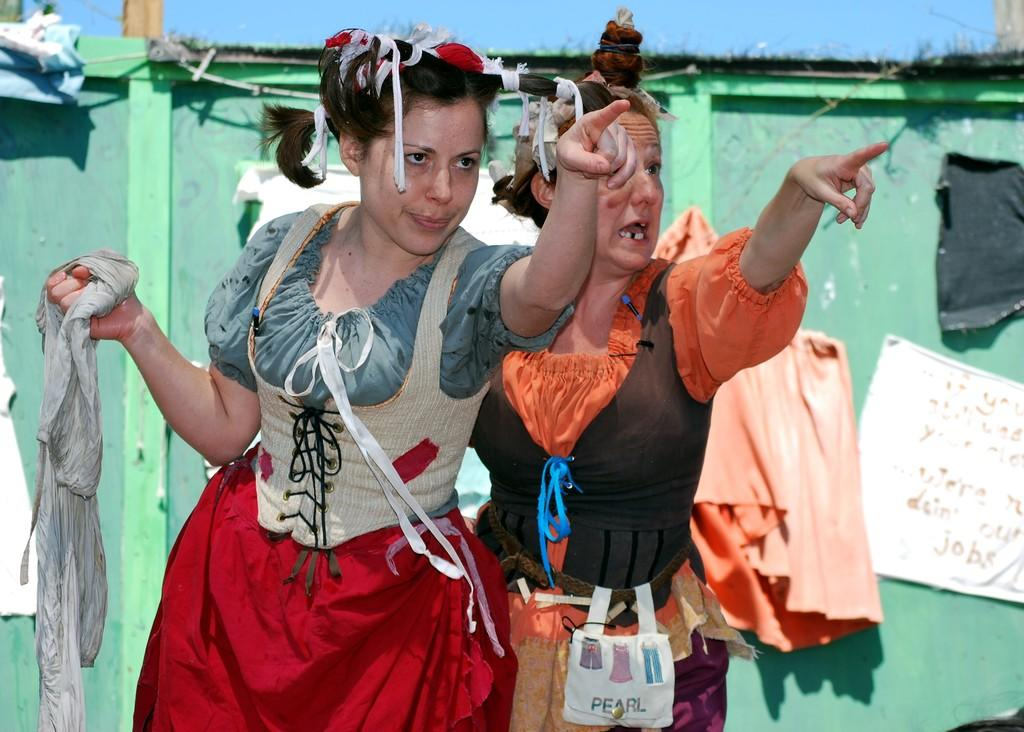What can be seen at the top of the image? The sky is visible at the top of the image. What is a prominent feature in the image? There is a door in the image. What is covering the door? Papers are placed over the door. How many women are in the image? There are two women standing in the image. What are the women doing in the image? The women are pointing towards a camera. What is one of the women holding in her hand? One of the women is holding a cloth in her hand. Where is the cover for the lunchroom located in the image? There is no mention of a lunchroom or a cover for it in the image. What type of loaf is being held by one of the women in the image? There is no loaf present in the image; one of the women is holding a cloth. 